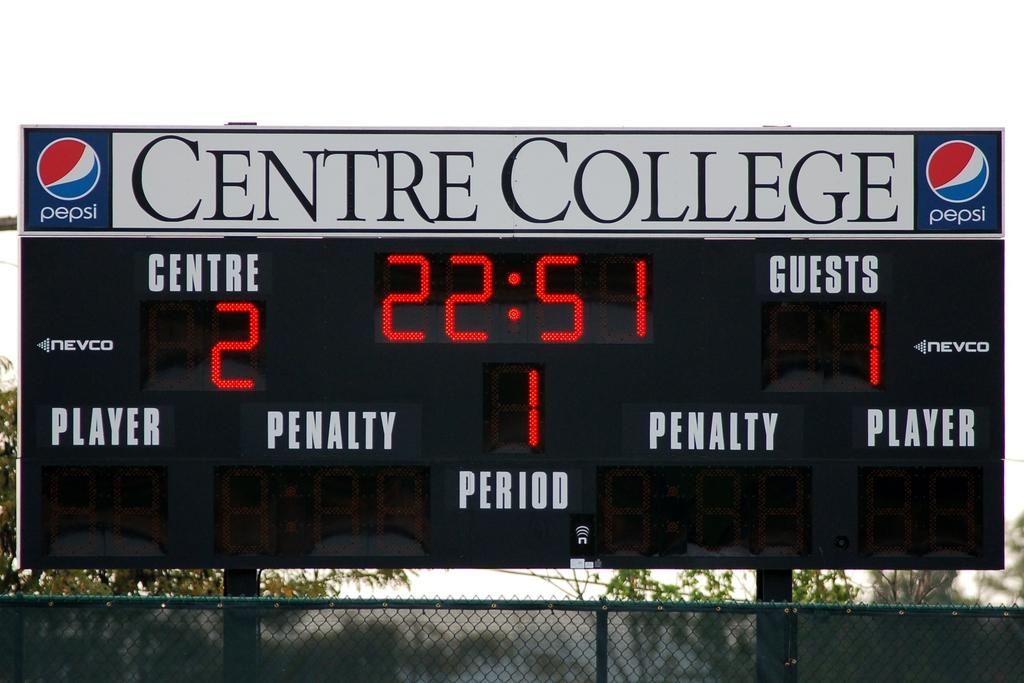Provide a one-sentence caption for the provided image. A scoreboard of a college sport game held at Centre College. 